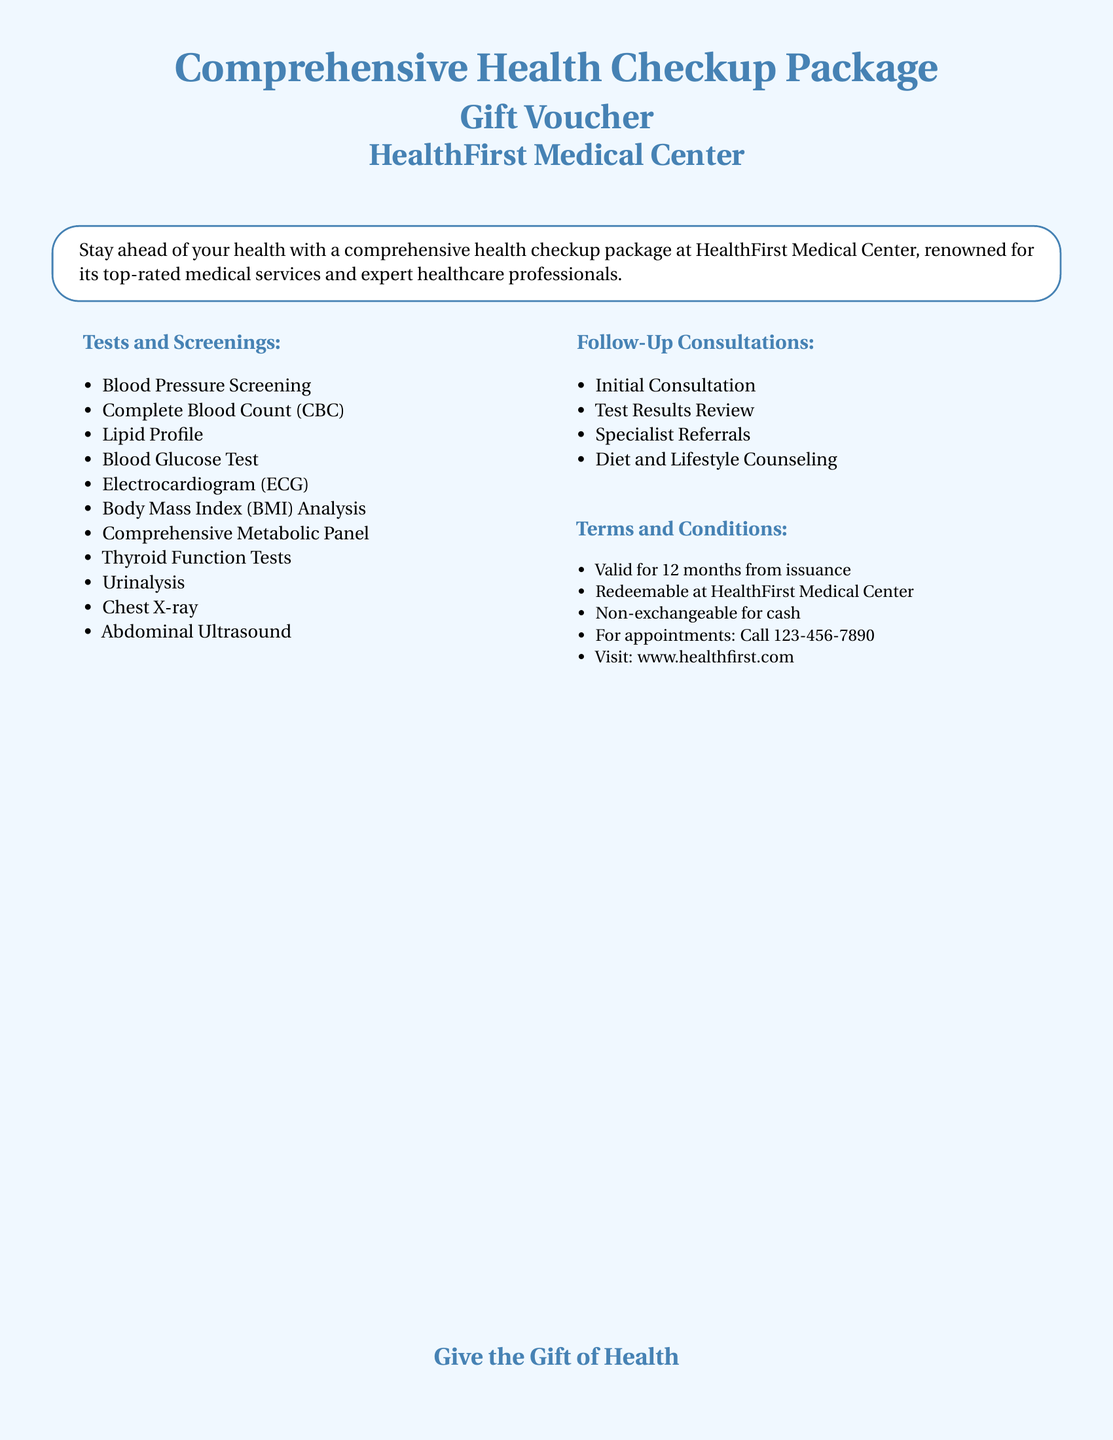what is the name of the medical facility? The document states that the gift voucher is for HealthFirst Medical Center.
Answer: HealthFirst Medical Center how many tests and screenings are included? The document lists 11 tests and screenings under that section.
Answer: 11 which test measures heart activity? The Electrocardiogram (ECG) is the test that measures heart activity.
Answer: Electrocardiogram (ECG) what is the validity period of the voucher? The document mentions that the voucher is valid for 12 months from issuance.
Answer: 12 months what type of counseling is included in the follow-up consultations? The document states that diet and lifestyle counseling is part of the follow-up consultations.
Answer: Diet and Lifestyle Counseling is the voucher exchangeable for cash? The document specifies that the voucher is non-exchangeable for cash.
Answer: Non-exchangeable for cash what should you do to make an appointment? According to the document, you need to call a specified number to make an appointment.
Answer: Call 123-456-7890 what is the website for HealthFirst Medical Center? The document provides a URL to visit for more information about HealthFirst Medical Center.
Answer: www.healthfirst.com 